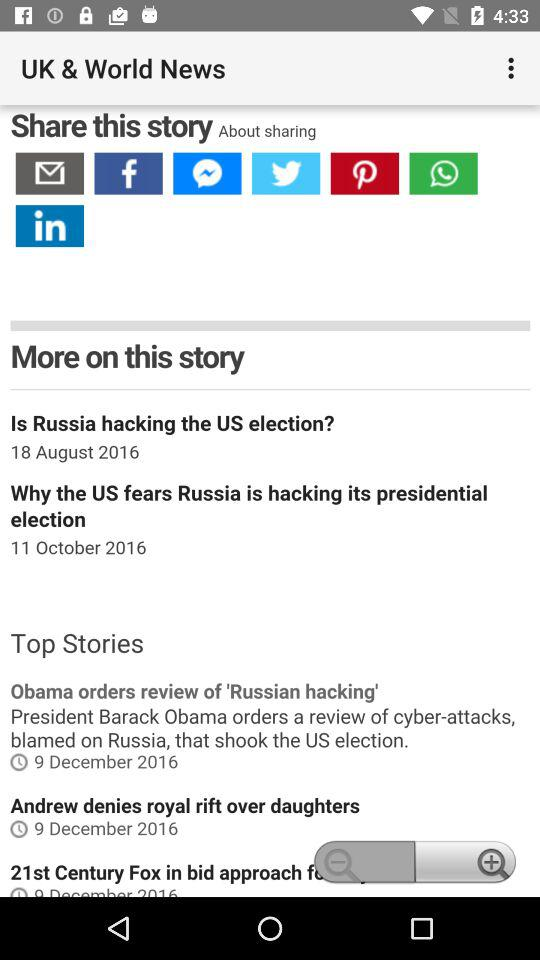What is the date for "Why the US fears Russia is hacking"? The date is October 11, 2016. 